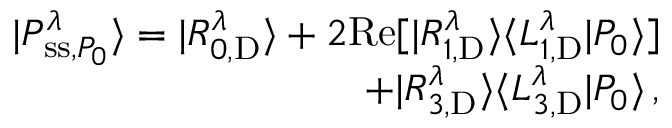<formula> <loc_0><loc_0><loc_500><loc_500>\begin{array} { r } { | P _ { s s , P _ { 0 } } ^ { \lambda } \rangle = | R _ { 0 , D } ^ { \lambda } \rangle + 2 R e [ | R _ { 1 , D } ^ { \lambda } \rangle \langle L _ { 1 , D } ^ { \lambda } | P _ { 0 } \rangle ] } \\ { + | R _ { 3 , D } ^ { \lambda } \rangle \langle L _ { 3 , D } ^ { \lambda } | P _ { 0 } \rangle \, , } \end{array}</formula> 